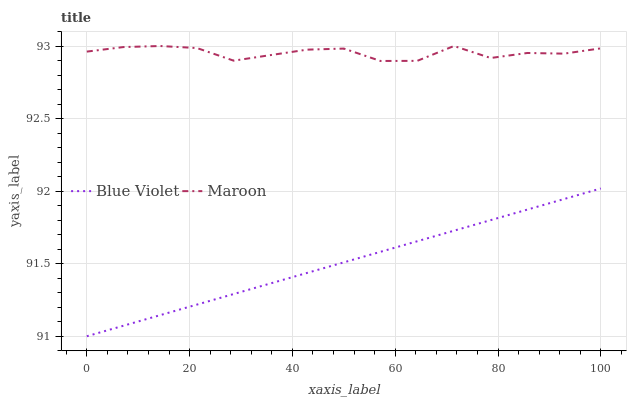Does Blue Violet have the minimum area under the curve?
Answer yes or no. Yes. Does Maroon have the maximum area under the curve?
Answer yes or no. Yes. Does Blue Violet have the maximum area under the curve?
Answer yes or no. No. Is Blue Violet the smoothest?
Answer yes or no. Yes. Is Maroon the roughest?
Answer yes or no. Yes. Is Blue Violet the roughest?
Answer yes or no. No. Does Blue Violet have the highest value?
Answer yes or no. No. Is Blue Violet less than Maroon?
Answer yes or no. Yes. Is Maroon greater than Blue Violet?
Answer yes or no. Yes. Does Blue Violet intersect Maroon?
Answer yes or no. No. 